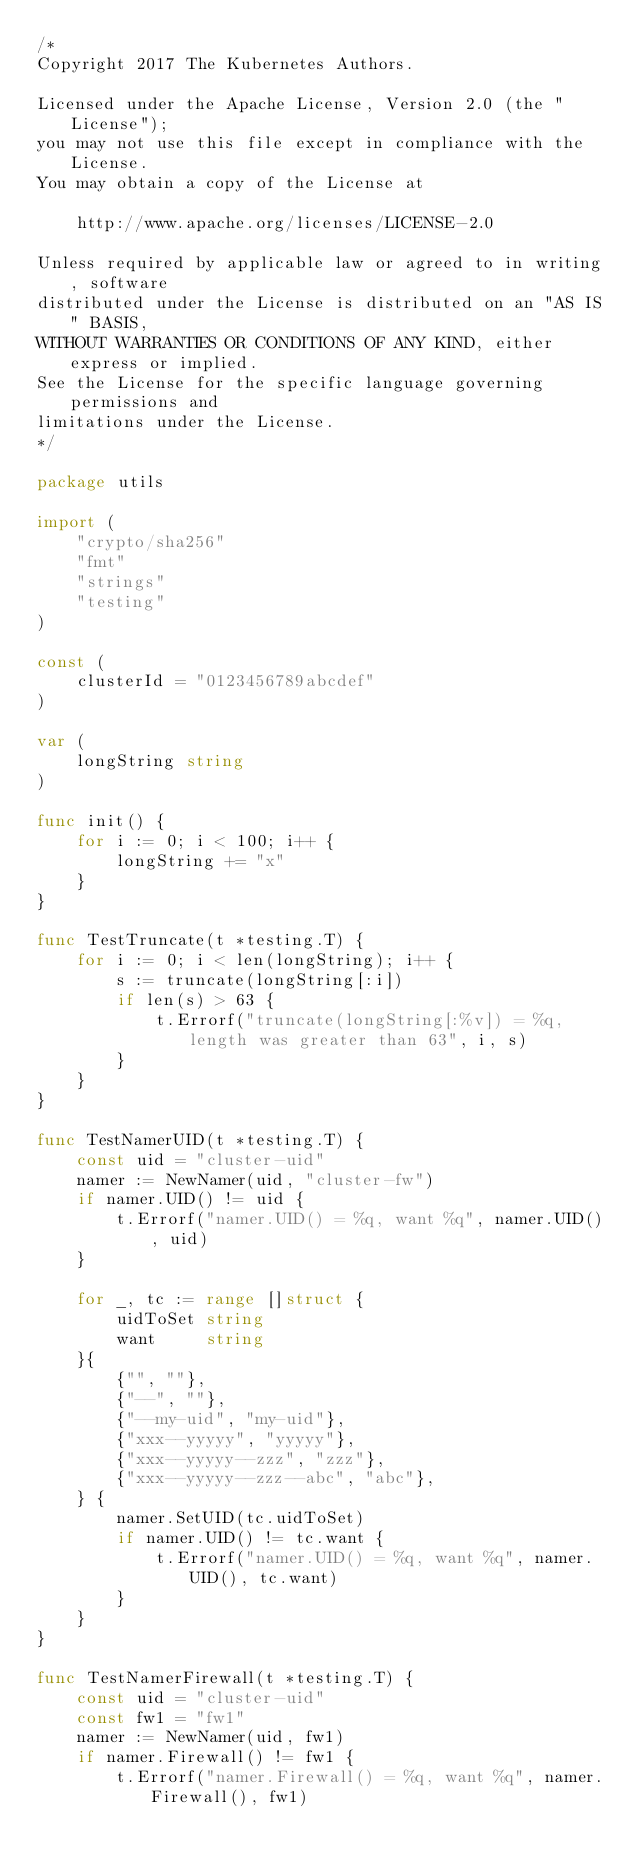<code> <loc_0><loc_0><loc_500><loc_500><_Go_>/*
Copyright 2017 The Kubernetes Authors.

Licensed under the Apache License, Version 2.0 (the "License");
you may not use this file except in compliance with the License.
You may obtain a copy of the License at

    http://www.apache.org/licenses/LICENSE-2.0

Unless required by applicable law or agreed to in writing, software
distributed under the License is distributed on an "AS IS" BASIS,
WITHOUT WARRANTIES OR CONDITIONS OF ANY KIND, either express or implied.
See the License for the specific language governing permissions and
limitations under the License.
*/

package utils

import (
	"crypto/sha256"
	"fmt"
	"strings"
	"testing"
)

const (
	clusterId = "0123456789abcdef"
)

var (
	longString string
)

func init() {
	for i := 0; i < 100; i++ {
		longString += "x"
	}
}

func TestTruncate(t *testing.T) {
	for i := 0; i < len(longString); i++ {
		s := truncate(longString[:i])
		if len(s) > 63 {
			t.Errorf("truncate(longString[:%v]) = %q, length was greater than 63", i, s)
		}
	}
}

func TestNamerUID(t *testing.T) {
	const uid = "cluster-uid"
	namer := NewNamer(uid, "cluster-fw")
	if namer.UID() != uid {
		t.Errorf("namer.UID() = %q, want %q", namer.UID(), uid)
	}

	for _, tc := range []struct {
		uidToSet string
		want     string
	}{
		{"", ""},
		{"--", ""},
		{"--my-uid", "my-uid"},
		{"xxx--yyyyy", "yyyyy"},
		{"xxx--yyyyy--zzz", "zzz"},
		{"xxx--yyyyy--zzz--abc", "abc"},
	} {
		namer.SetUID(tc.uidToSet)
		if namer.UID() != tc.want {
			t.Errorf("namer.UID() = %q, want %q", namer.UID(), tc.want)
		}
	}
}

func TestNamerFirewall(t *testing.T) {
	const uid = "cluster-uid"
	const fw1 = "fw1"
	namer := NewNamer(uid, fw1)
	if namer.Firewall() != fw1 {
		t.Errorf("namer.Firewall() = %q, want %q", namer.Firewall(), fw1)</code> 